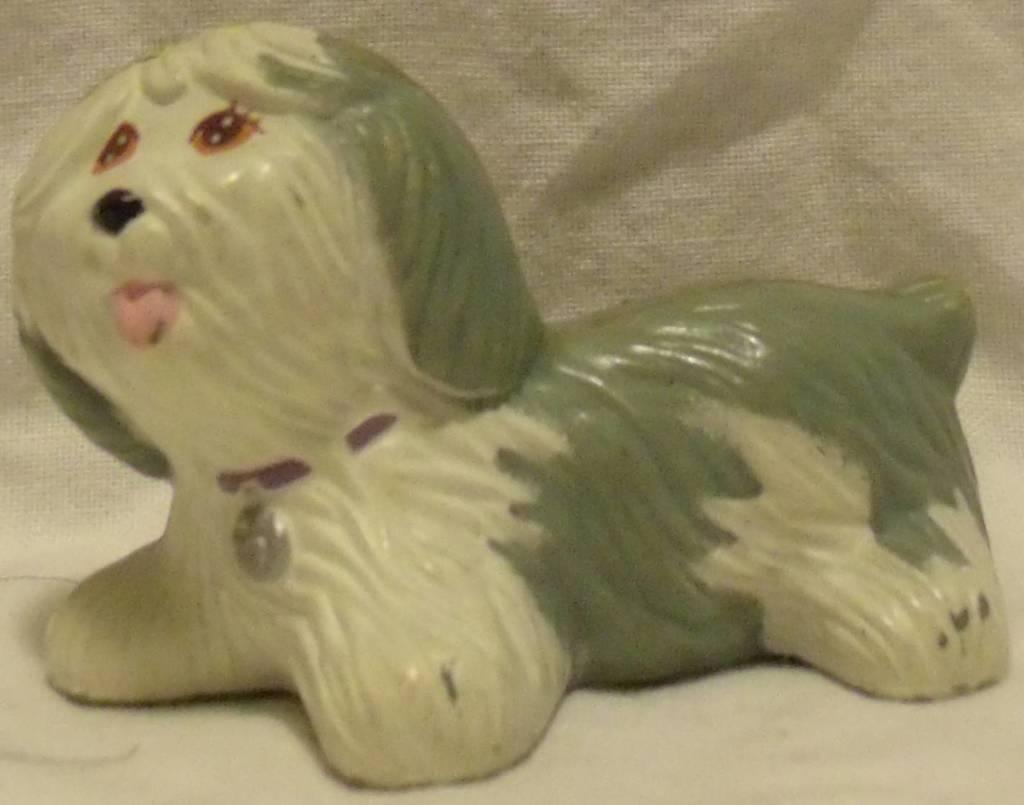What is the main subject of the picture? The main subject of the picture is a dog sculpture. What color is the dog sculpture? The dog sculpture is cream in color. Are there any other colors present on the dog sculpture? Yes, some parts of the dog sculpture are light green in color. What type of loaf is the dog sculpture holding in the image? There is no loaf present in the image; it features a dog sculpture with cream and light green colors. Who is the manager of the giants in the image? There are no giants or managers present in the image; it only contains a dog sculpture. 